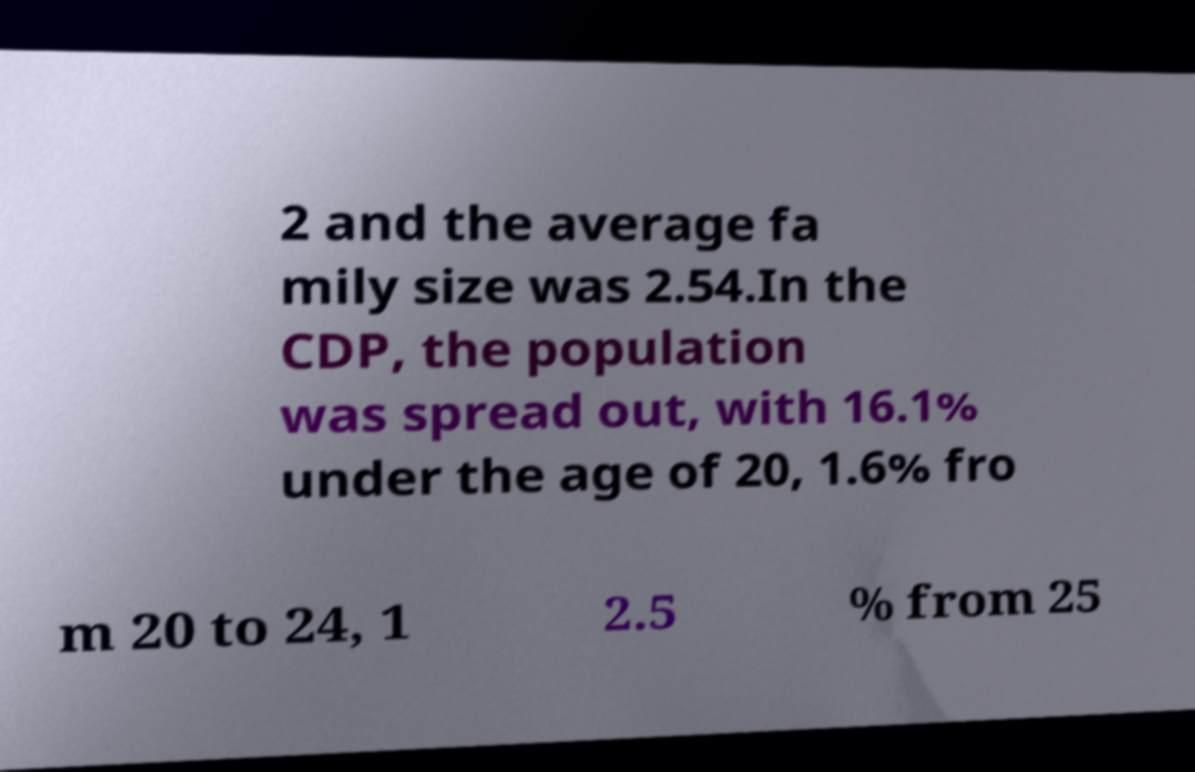Can you read and provide the text displayed in the image?This photo seems to have some interesting text. Can you extract and type it out for me? 2 and the average fa mily size was 2.54.In the CDP, the population was spread out, with 16.1% under the age of 20, 1.6% fro m 20 to 24, 1 2.5 % from 25 